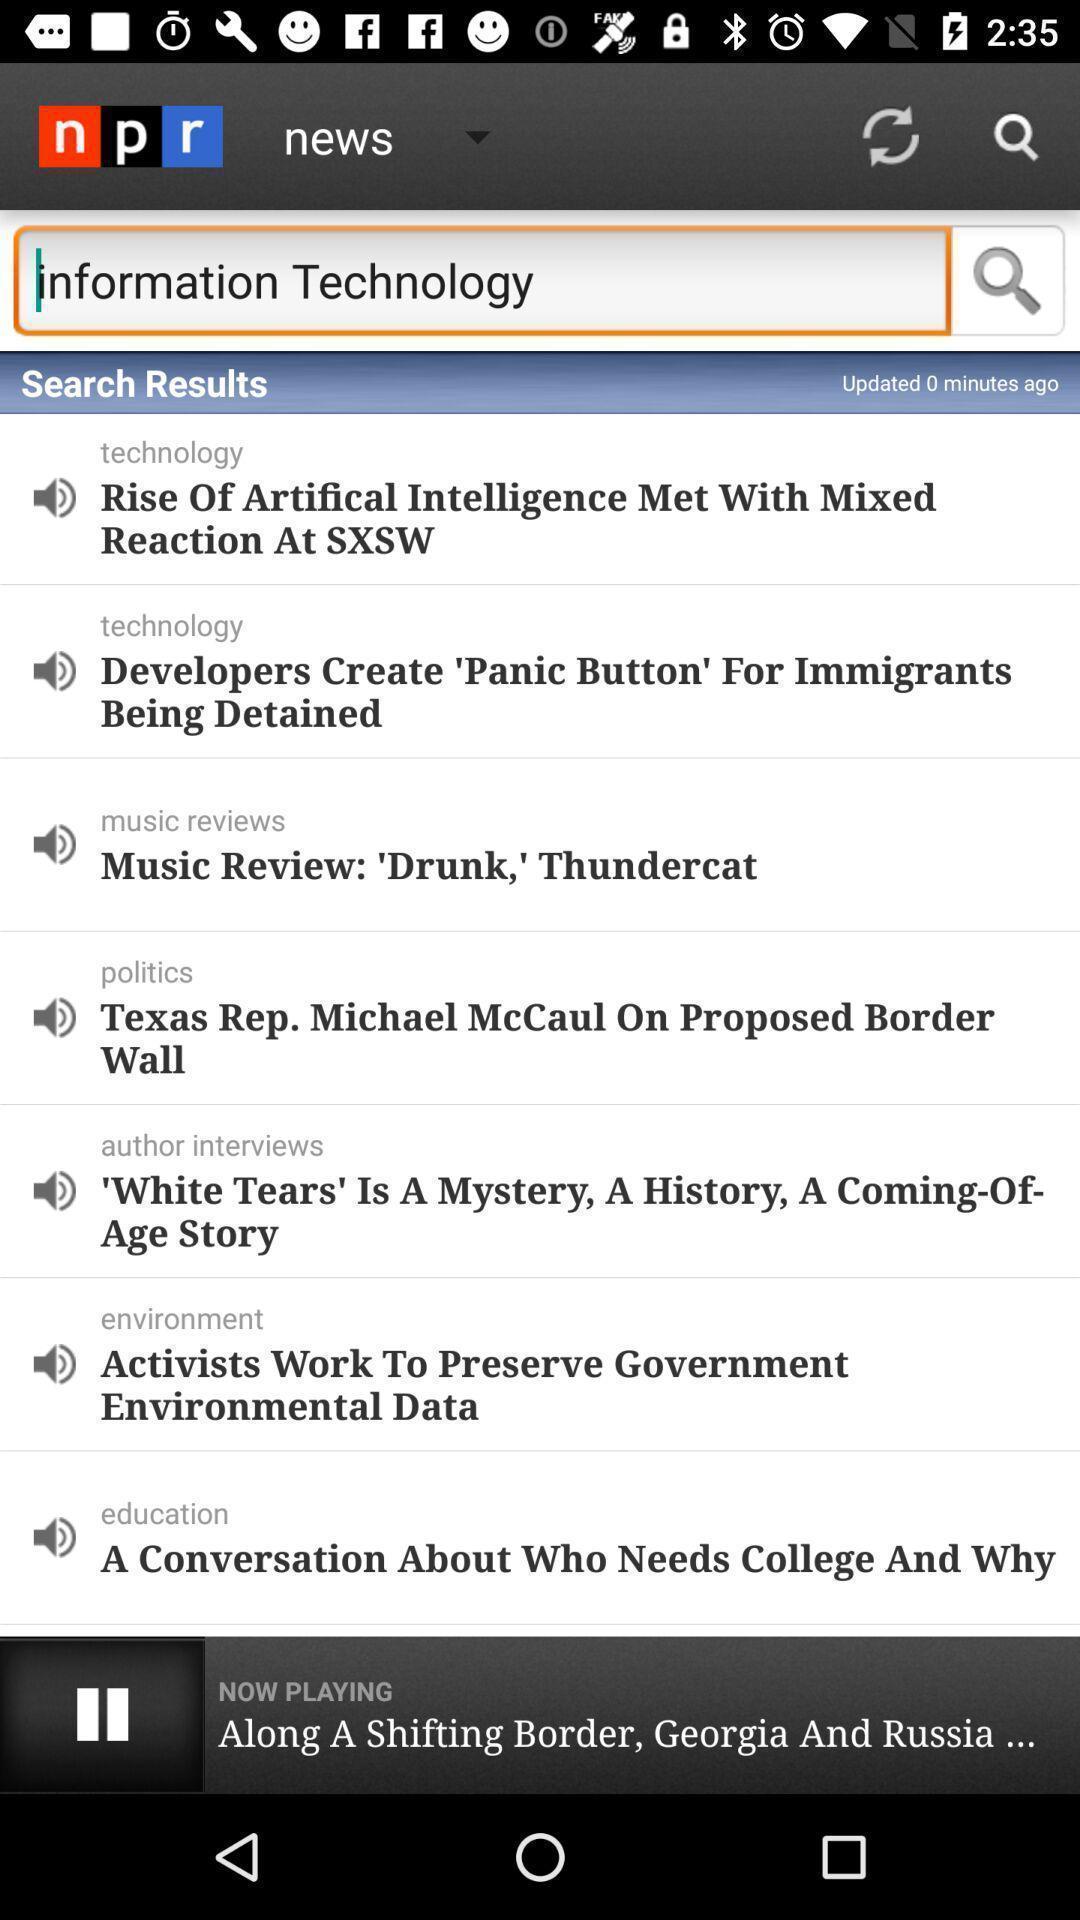Describe the content in this image. Screen displaying the news page. 